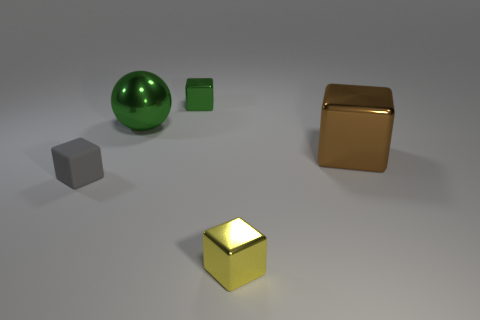Subtract 1 blocks. How many blocks are left? 3 Add 4 tiny yellow metal cubes. How many objects exist? 9 Subtract all balls. How many objects are left? 4 Add 4 small cubes. How many small cubes exist? 7 Subtract 0 red cubes. How many objects are left? 5 Subtract all rubber blocks. Subtract all small gray matte things. How many objects are left? 3 Add 2 tiny metallic blocks. How many tiny metallic blocks are left? 4 